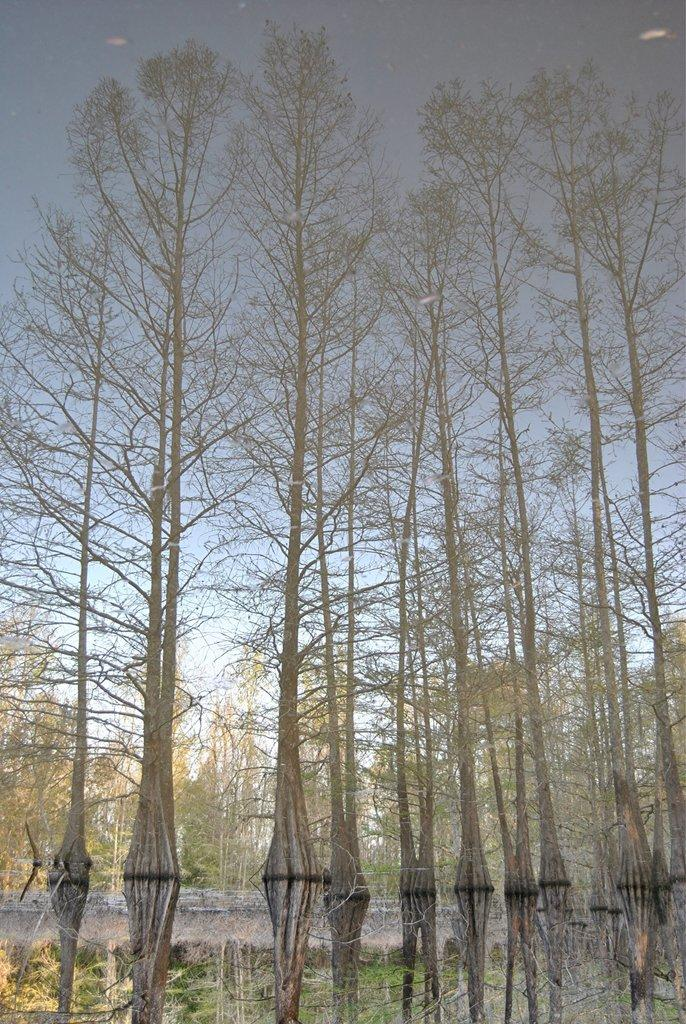What type of vegetation can be seen in the image? There are trees in the image. What part of the natural environment is visible in the image? The sky is visible in the background of the image. What is the chance of the trees shaking in the image? There is no indication in the image that the trees are shaking, and therefore it is not possible to determine the chance of them doing so. 